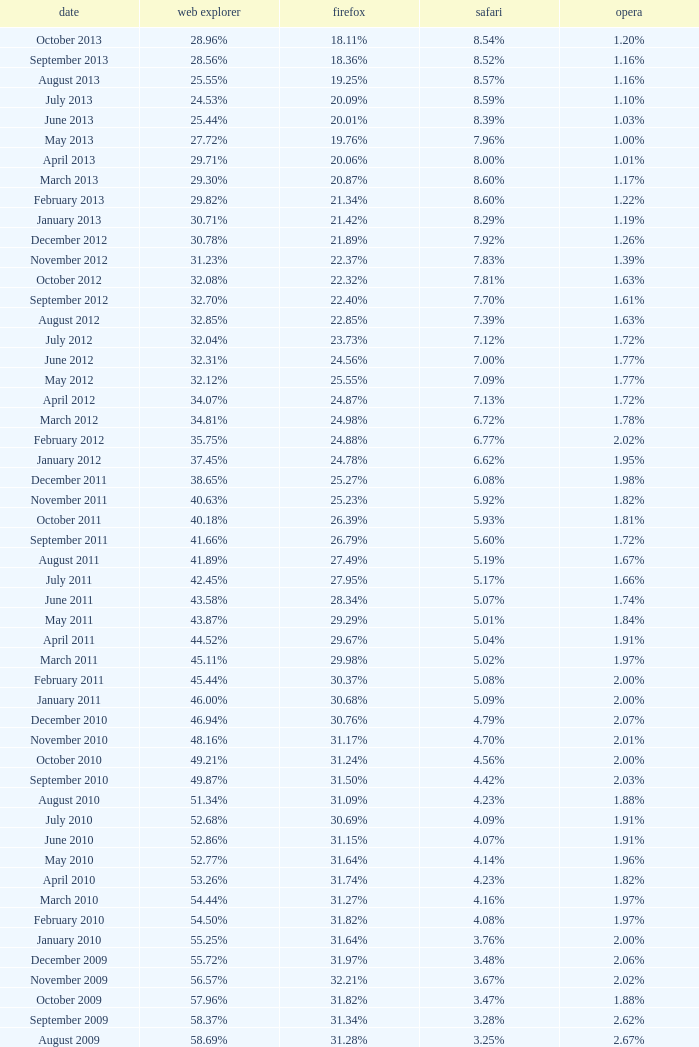What percentage of browsers were using Safari during the period in which 31.27% were using Firefox? 4.16%. 